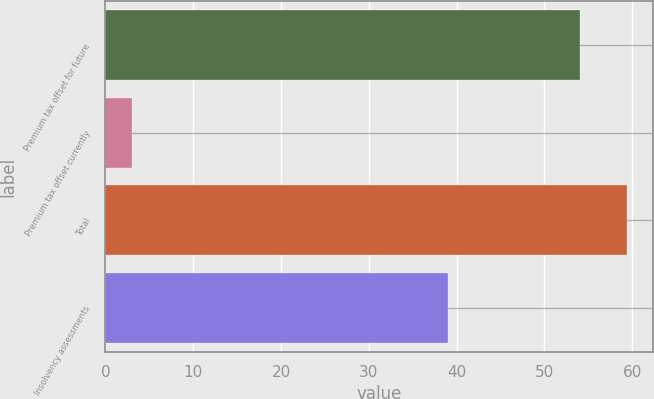Convert chart to OTSL. <chart><loc_0><loc_0><loc_500><loc_500><bar_chart><fcel>Premium tax offset for future<fcel>Premium tax offset currently<fcel>Total<fcel>Insolvency assessments<nl><fcel>54<fcel>3<fcel>59.4<fcel>39<nl></chart> 